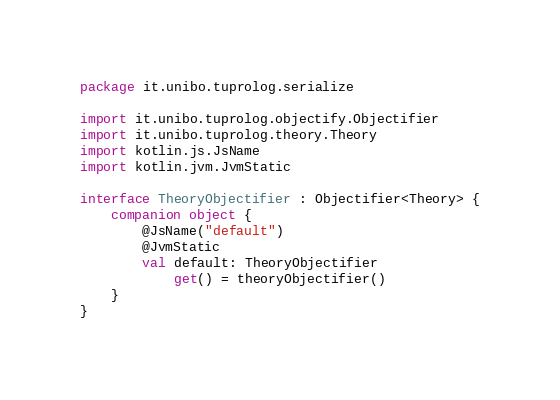Convert code to text. <code><loc_0><loc_0><loc_500><loc_500><_Kotlin_>package it.unibo.tuprolog.serialize

import it.unibo.tuprolog.objectify.Objectifier
import it.unibo.tuprolog.theory.Theory
import kotlin.js.JsName
import kotlin.jvm.JvmStatic

interface TheoryObjectifier : Objectifier<Theory> {
    companion object {
        @JsName("default")
        @JvmStatic
        val default: TheoryObjectifier
            get() = theoryObjectifier()
    }
}</code> 